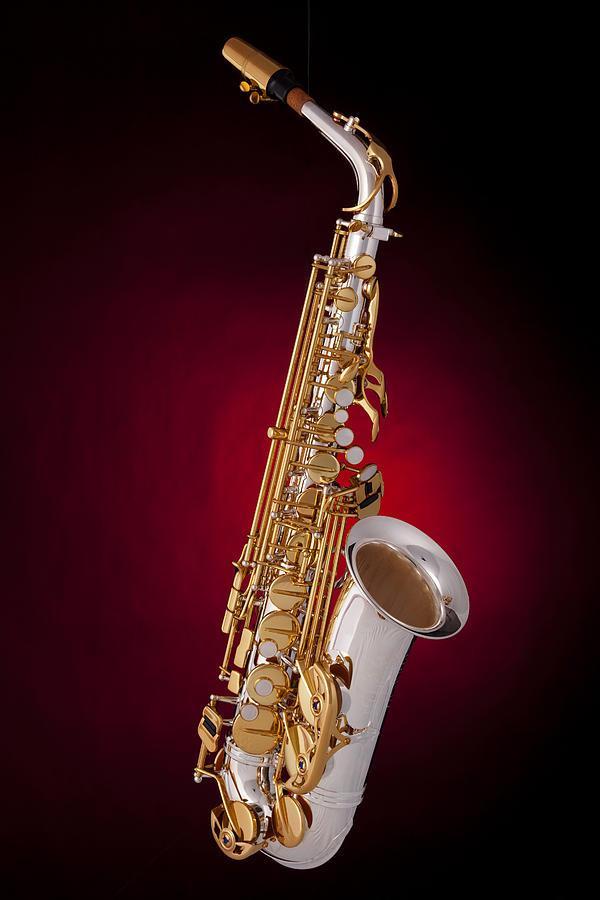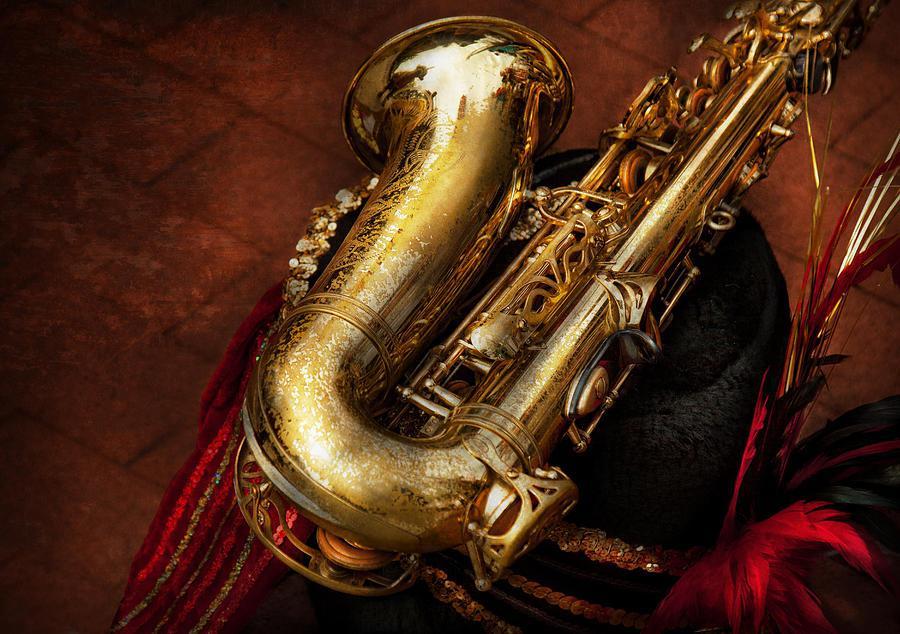The first image is the image on the left, the second image is the image on the right. For the images shown, is this caption "All the instruments are on a stand." true? Answer yes or no. No. 